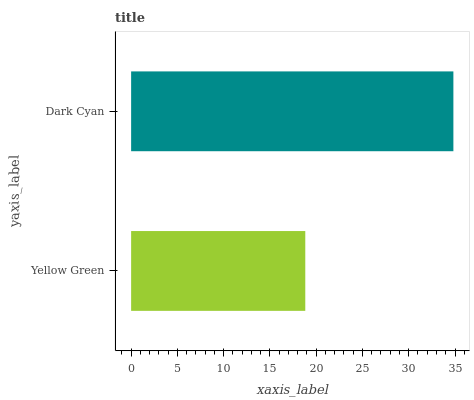Is Yellow Green the minimum?
Answer yes or no. Yes. Is Dark Cyan the maximum?
Answer yes or no. Yes. Is Dark Cyan the minimum?
Answer yes or no. No. Is Dark Cyan greater than Yellow Green?
Answer yes or no. Yes. Is Yellow Green less than Dark Cyan?
Answer yes or no. Yes. Is Yellow Green greater than Dark Cyan?
Answer yes or no. No. Is Dark Cyan less than Yellow Green?
Answer yes or no. No. Is Dark Cyan the high median?
Answer yes or no. Yes. Is Yellow Green the low median?
Answer yes or no. Yes. Is Yellow Green the high median?
Answer yes or no. No. Is Dark Cyan the low median?
Answer yes or no. No. 